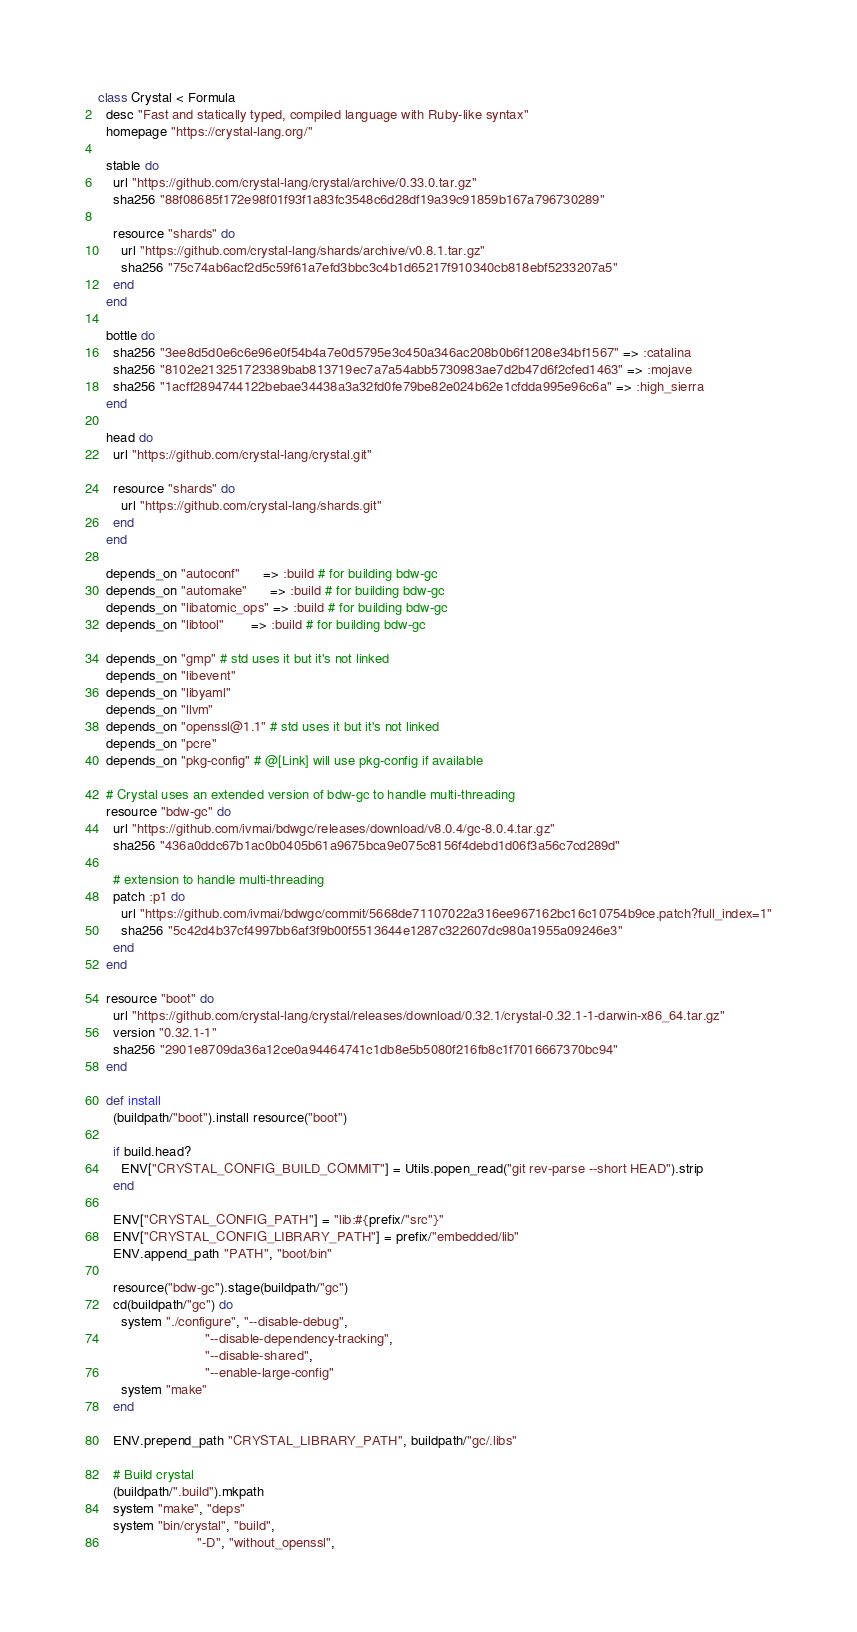<code> <loc_0><loc_0><loc_500><loc_500><_Ruby_>class Crystal < Formula
  desc "Fast and statically typed, compiled language with Ruby-like syntax"
  homepage "https://crystal-lang.org/"

  stable do
    url "https://github.com/crystal-lang/crystal/archive/0.33.0.tar.gz"
    sha256 "88f08685f172e98f01f93f1a83fc3548c6d28df19a39c91859b167a796730289"

    resource "shards" do
      url "https://github.com/crystal-lang/shards/archive/v0.8.1.tar.gz"
      sha256 "75c74ab6acf2d5c59f61a7efd3bbc3c4b1d65217f910340cb818ebf5233207a5"
    end
  end

  bottle do
    sha256 "3ee8d5d0e6c6e96e0f54b4a7e0d5795e3c450a346ac208b0b6f1208e34bf1567" => :catalina
    sha256 "8102e213251723389bab813719ec7a7a54abb5730983ae7d2b47d6f2cfed1463" => :mojave
    sha256 "1acff2894744122bebae34438a3a32fd0fe79be82e024b62e1cfdda995e96c6a" => :high_sierra
  end

  head do
    url "https://github.com/crystal-lang/crystal.git"

    resource "shards" do
      url "https://github.com/crystal-lang/shards.git"
    end
  end

  depends_on "autoconf"      => :build # for building bdw-gc
  depends_on "automake"      => :build # for building bdw-gc
  depends_on "libatomic_ops" => :build # for building bdw-gc
  depends_on "libtool"       => :build # for building bdw-gc

  depends_on "gmp" # std uses it but it's not linked
  depends_on "libevent"
  depends_on "libyaml"
  depends_on "llvm"
  depends_on "openssl@1.1" # std uses it but it's not linked
  depends_on "pcre"
  depends_on "pkg-config" # @[Link] will use pkg-config if available

  # Crystal uses an extended version of bdw-gc to handle multi-threading
  resource "bdw-gc" do
    url "https://github.com/ivmai/bdwgc/releases/download/v8.0.4/gc-8.0.4.tar.gz"
    sha256 "436a0ddc67b1ac0b0405b61a9675bca9e075c8156f4debd1d06f3a56c7cd289d"

    # extension to handle multi-threading
    patch :p1 do
      url "https://github.com/ivmai/bdwgc/commit/5668de71107022a316ee967162bc16c10754b9ce.patch?full_index=1"
      sha256 "5c42d4b37cf4997bb6af3f9b00f5513644e1287c322607dc980a1955a09246e3"
    end
  end

  resource "boot" do
    url "https://github.com/crystal-lang/crystal/releases/download/0.32.1/crystal-0.32.1-1-darwin-x86_64.tar.gz"
    version "0.32.1-1"
    sha256 "2901e8709da36a12ce0a94464741c1db8e5b5080f216fb8c1f7016667370bc94"
  end

  def install
    (buildpath/"boot").install resource("boot")

    if build.head?
      ENV["CRYSTAL_CONFIG_BUILD_COMMIT"] = Utils.popen_read("git rev-parse --short HEAD").strip
    end

    ENV["CRYSTAL_CONFIG_PATH"] = "lib:#{prefix/"src"}"
    ENV["CRYSTAL_CONFIG_LIBRARY_PATH"] = prefix/"embedded/lib"
    ENV.append_path "PATH", "boot/bin"

    resource("bdw-gc").stage(buildpath/"gc")
    cd(buildpath/"gc") do
      system "./configure", "--disable-debug",
                            "--disable-dependency-tracking",
                            "--disable-shared",
                            "--enable-large-config"
      system "make"
    end

    ENV.prepend_path "CRYSTAL_LIBRARY_PATH", buildpath/"gc/.libs"

    # Build crystal
    (buildpath/".build").mkpath
    system "make", "deps"
    system "bin/crystal", "build",
                          "-D", "without_openssl",</code> 